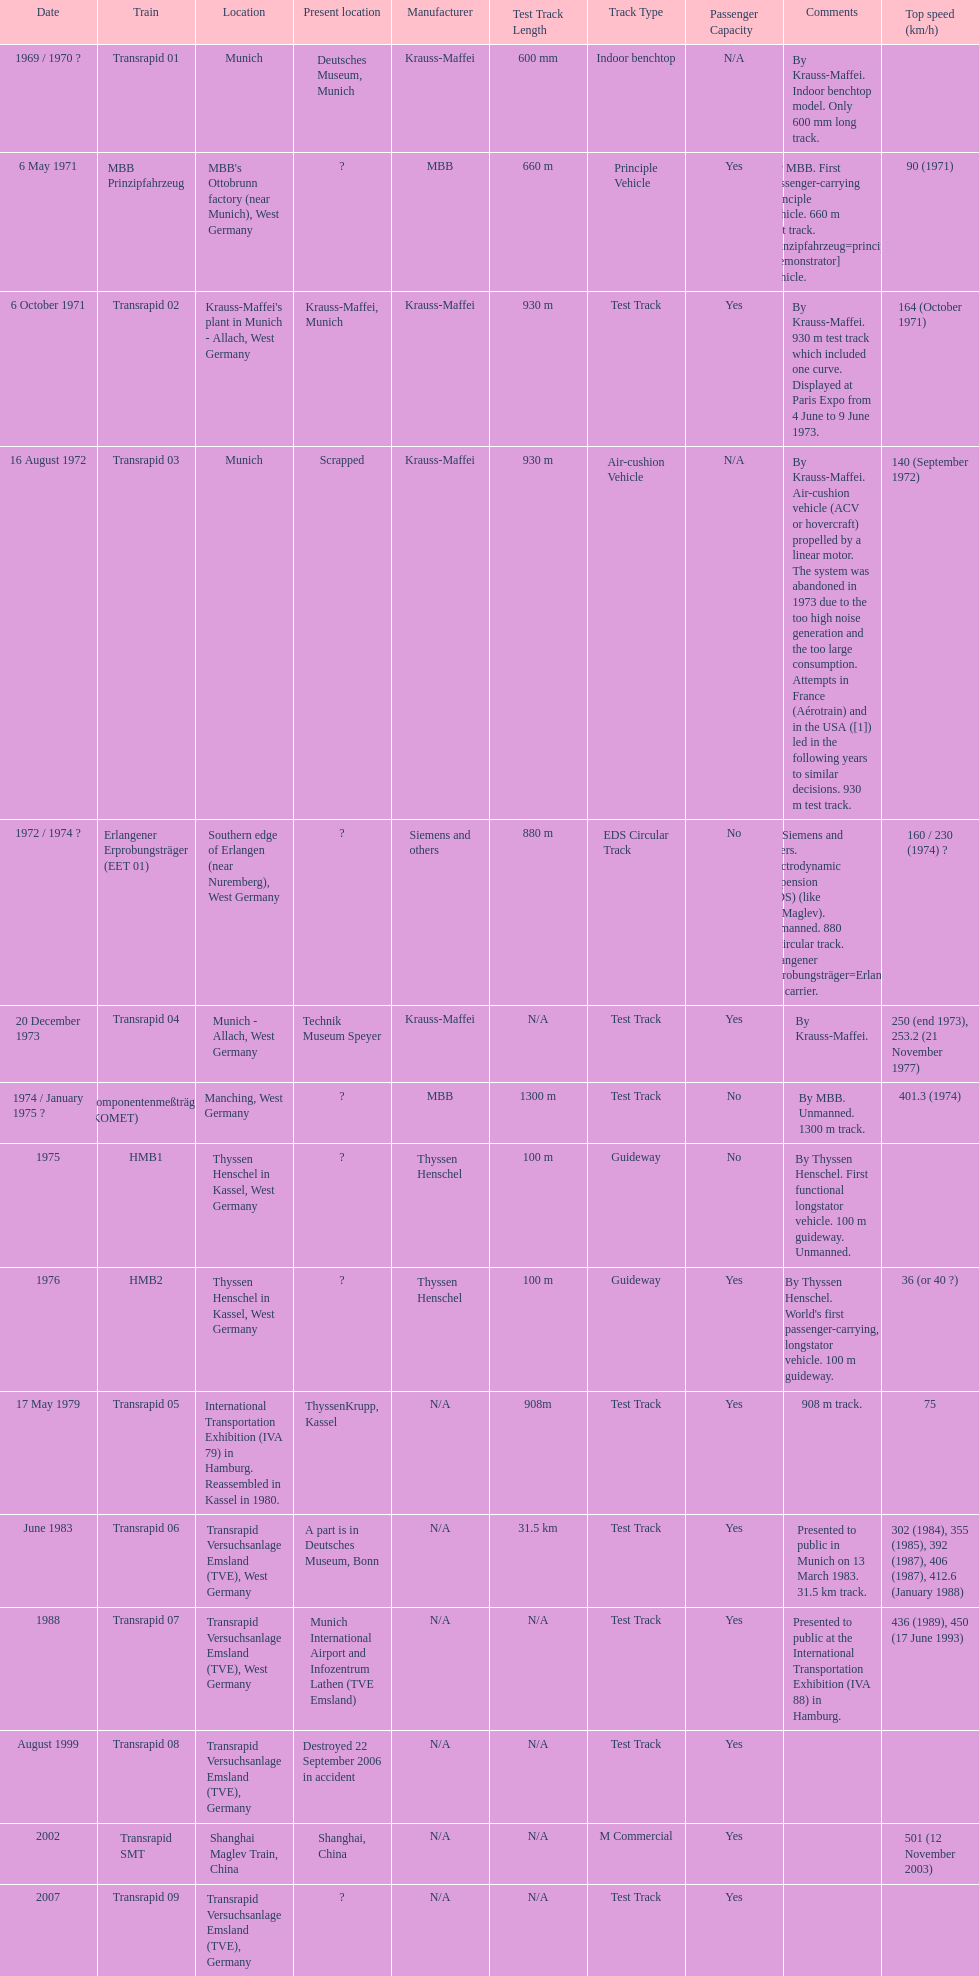What train was developed after the erlangener erprobungstrager? Transrapid 04. 